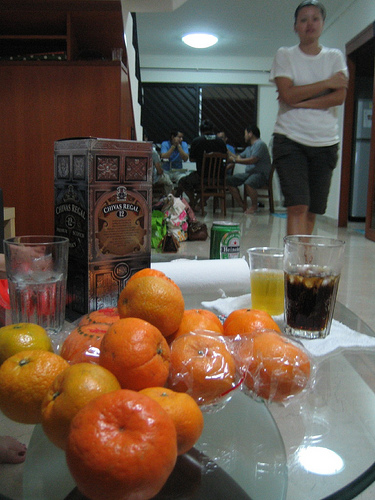Describe the items in the foreground. In the foreground, there's a clear glass table holding several ripe oranges, some of which are partially peeled. There are also two glasses; one has a clear liquid that could be water, and the other has a dark liquid that resembles soda or iced coffee. Additionally, a box labeled 'Costa Rica Coffee' suggests that coffee might be part of the beverage selection at this gathering. 